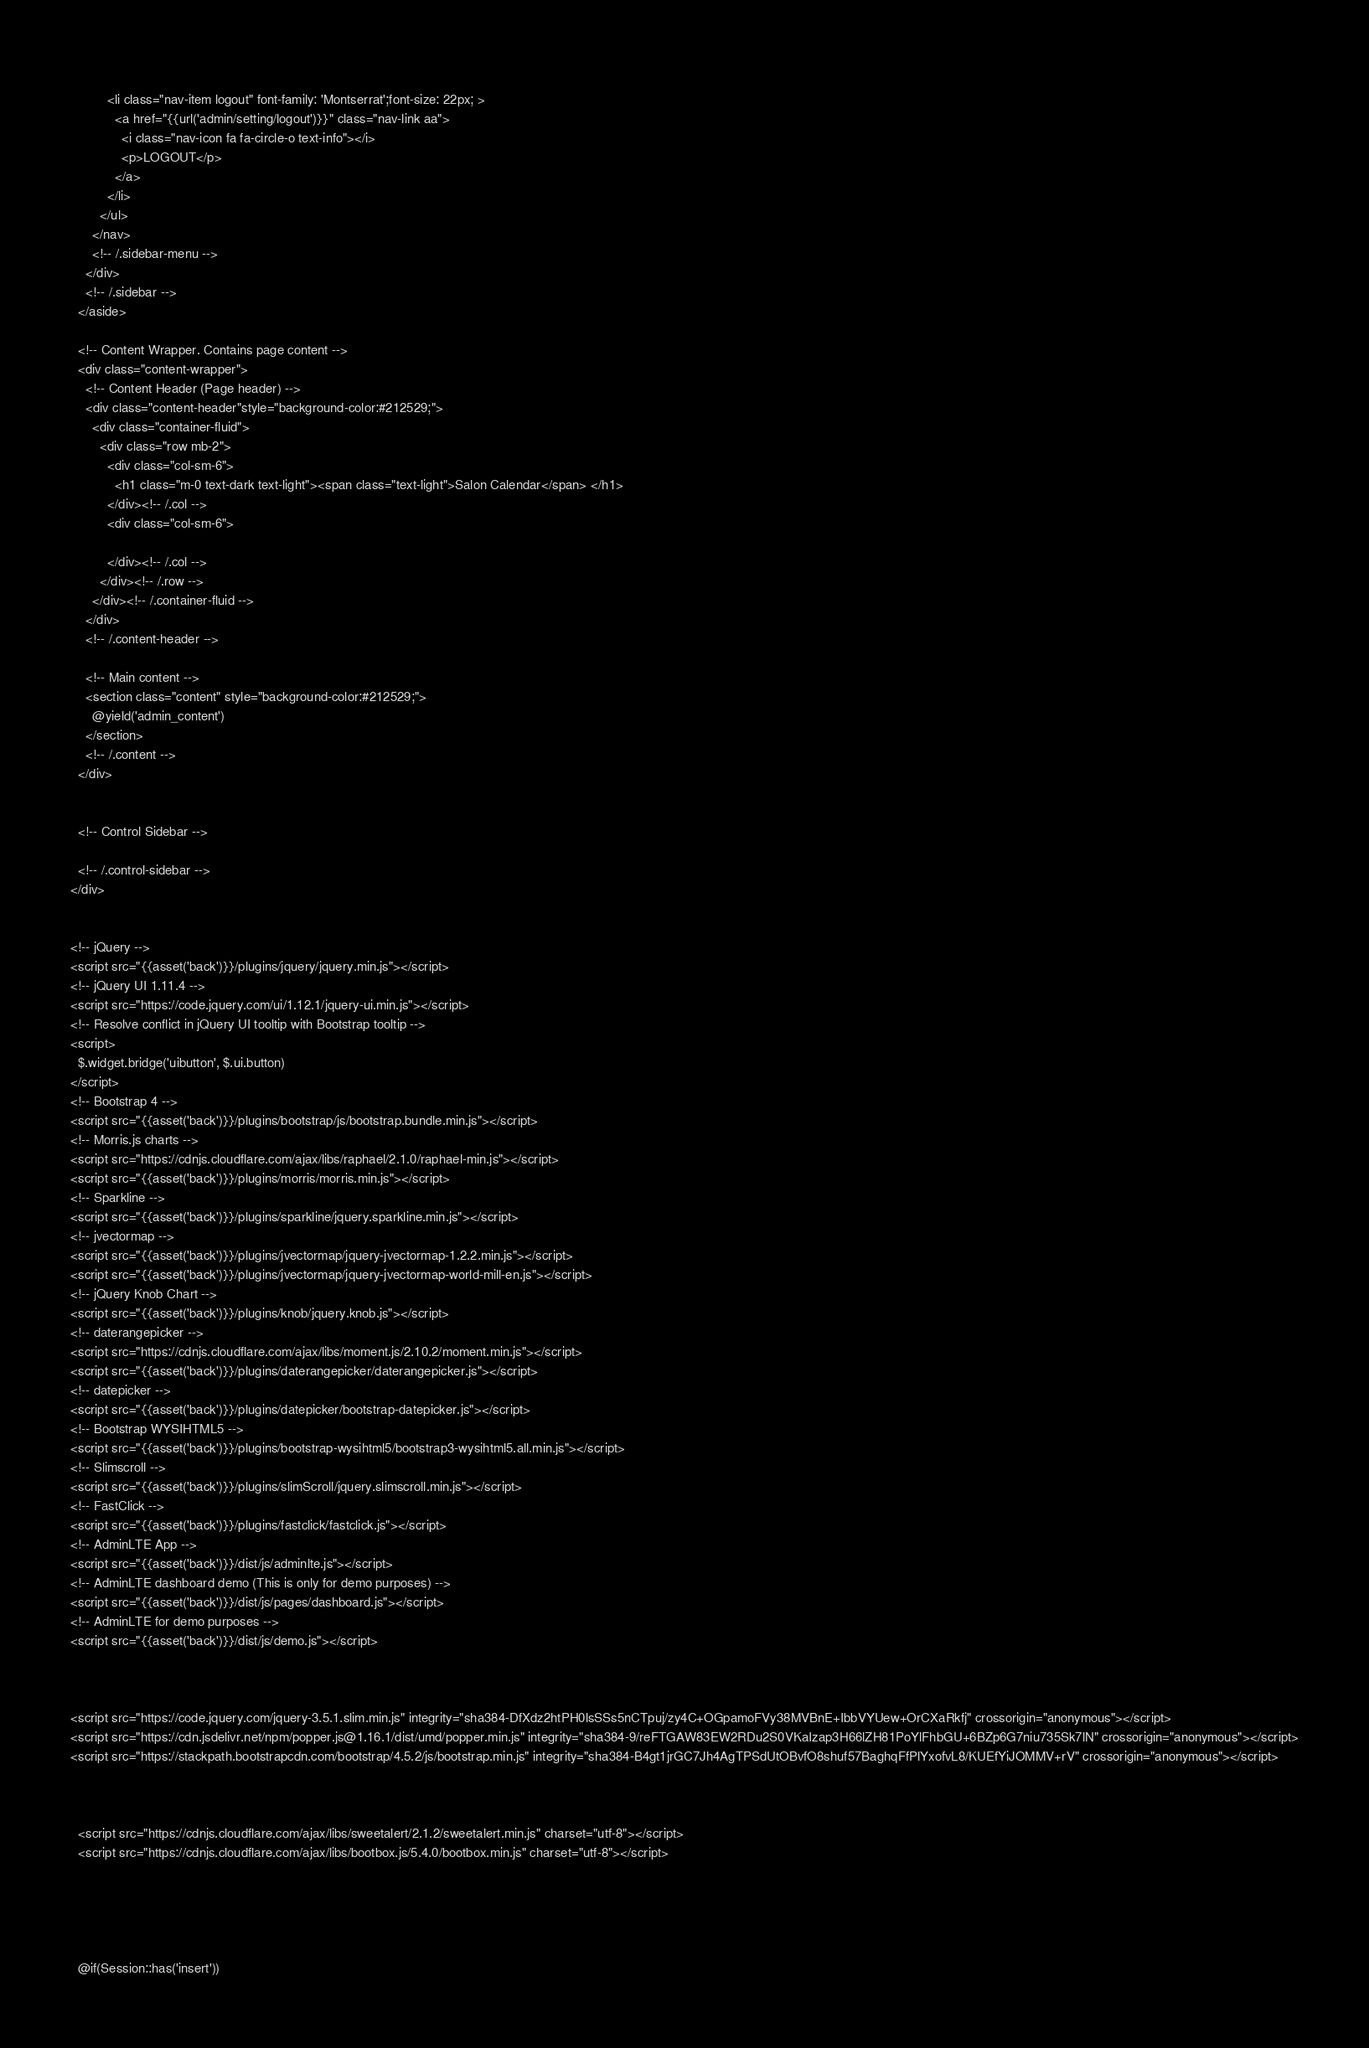Convert code to text. <code><loc_0><loc_0><loc_500><loc_500><_PHP_>          
          <li class="nav-item logout" font-family: 'Montserrat';font-size: 22px; >
            <a href="{{url('admin/setting/logout')}}" class="nav-link aa">
              <i class="nav-icon fa fa-circle-o text-info"></i>
              <p>LOGOUT</p>
            </a>
          </li>
        </ul>
      </nav>
      <!-- /.sidebar-menu -->
    </div>
    <!-- /.sidebar -->
  </aside>

  <!-- Content Wrapper. Contains page content -->
  <div class="content-wrapper">
    <!-- Content Header (Page header) -->
    <div class="content-header"style="background-color:#212529;">
      <div class="container-fluid">
        <div class="row mb-2">
          <div class="col-sm-6">
            <h1 class="m-0 text-dark text-light"><span class="text-light">Salon Calendar</span> </h1>
          </div><!-- /.col -->
          <div class="col-sm-6">
            
          </div><!-- /.col -->
        </div><!-- /.row -->
      </div><!-- /.container-fluid -->
    </div>
    <!-- /.content-header -->

    <!-- Main content -->
    <section class="content" style="background-color:#212529;">
      @yield('admin_content')
    </section>
    <!-- /.content -->
  </div>


  <!-- Control Sidebar -->

  <!-- /.control-sidebar -->
</div>


<!-- jQuery -->
<script src="{{asset('back')}}/plugins/jquery/jquery.min.js"></script>
<!-- jQuery UI 1.11.4 -->
<script src="https://code.jquery.com/ui/1.12.1/jquery-ui.min.js"></script>
<!-- Resolve conflict in jQuery UI tooltip with Bootstrap tooltip -->
<script>
  $.widget.bridge('uibutton', $.ui.button)
</script>
<!-- Bootstrap 4 -->
<script src="{{asset('back')}}/plugins/bootstrap/js/bootstrap.bundle.min.js"></script>
<!-- Morris.js charts -->
<script src="https://cdnjs.cloudflare.com/ajax/libs/raphael/2.1.0/raphael-min.js"></script>
<script src="{{asset('back')}}/plugins/morris/morris.min.js"></script>
<!-- Sparkline -->
<script src="{{asset('back')}}/plugins/sparkline/jquery.sparkline.min.js"></script>
<!-- jvectormap -->
<script src="{{asset('back')}}/plugins/jvectormap/jquery-jvectormap-1.2.2.min.js"></script>
<script src="{{asset('back')}}/plugins/jvectormap/jquery-jvectormap-world-mill-en.js"></script>
<!-- jQuery Knob Chart -->
<script src="{{asset('back')}}/plugins/knob/jquery.knob.js"></script>
<!-- daterangepicker -->
<script src="https://cdnjs.cloudflare.com/ajax/libs/moment.js/2.10.2/moment.min.js"></script>
<script src="{{asset('back')}}/plugins/daterangepicker/daterangepicker.js"></script>
<!-- datepicker -->
<script src="{{asset('back')}}/plugins/datepicker/bootstrap-datepicker.js"></script>
<!-- Bootstrap WYSIHTML5 -->
<script src="{{asset('back')}}/plugins/bootstrap-wysihtml5/bootstrap3-wysihtml5.all.min.js"></script>
<!-- Slimscroll -->
<script src="{{asset('back')}}/plugins/slimScroll/jquery.slimscroll.min.js"></script>
<!-- FastClick -->
<script src="{{asset('back')}}/plugins/fastclick/fastclick.js"></script>
<!-- AdminLTE App -->
<script src="{{asset('back')}}/dist/js/adminlte.js"></script>
<!-- AdminLTE dashboard demo (This is only for demo purposes) -->
<script src="{{asset('back')}}/dist/js/pages/dashboard.js"></script>
<!-- AdminLTE for demo purposes -->
<script src="{{asset('back')}}/dist/js/demo.js"></script>



<script src="https://code.jquery.com/jquery-3.5.1.slim.min.js" integrity="sha384-DfXdz2htPH0lsSSs5nCTpuj/zy4C+OGpamoFVy38MVBnE+IbbVYUew+OrCXaRkfj" crossorigin="anonymous"></script>
<script src="https://cdn.jsdelivr.net/npm/popper.js@1.16.1/dist/umd/popper.min.js" integrity="sha384-9/reFTGAW83EW2RDu2S0VKaIzap3H66lZH81PoYlFhbGU+6BZp6G7niu735Sk7lN" crossorigin="anonymous"></script>
<script src="https://stackpath.bootstrapcdn.com/bootstrap/4.5.2/js/bootstrap.min.js" integrity="sha384-B4gt1jrGC7Jh4AgTPSdUtOBvfO8shuf57BaghqFfPlYxofvL8/KUEfYiJOMMV+rV" crossorigin="anonymous"></script>



  <script src="https://cdnjs.cloudflare.com/ajax/libs/sweetalert/2.1.2/sweetalert.min.js" charset="utf-8"></script>
  <script src="https://cdnjs.cloudflare.com/ajax/libs/bootbox.js/5.4.0/bootbox.min.js" charset="utf-8"></script>





  @if(Session::has('insert'))</code> 